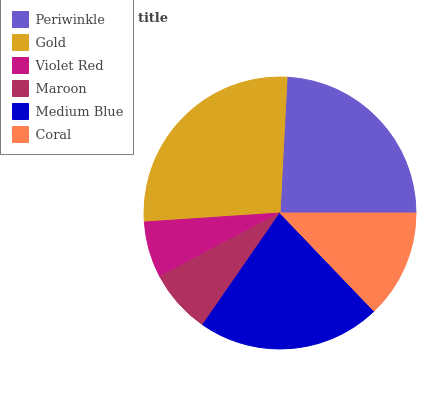Is Violet Red the minimum?
Answer yes or no. Yes. Is Gold the maximum?
Answer yes or no. Yes. Is Gold the minimum?
Answer yes or no. No. Is Violet Red the maximum?
Answer yes or no. No. Is Gold greater than Violet Red?
Answer yes or no. Yes. Is Violet Red less than Gold?
Answer yes or no. Yes. Is Violet Red greater than Gold?
Answer yes or no. No. Is Gold less than Violet Red?
Answer yes or no. No. Is Medium Blue the high median?
Answer yes or no. Yes. Is Coral the low median?
Answer yes or no. Yes. Is Violet Red the high median?
Answer yes or no. No. Is Gold the low median?
Answer yes or no. No. 